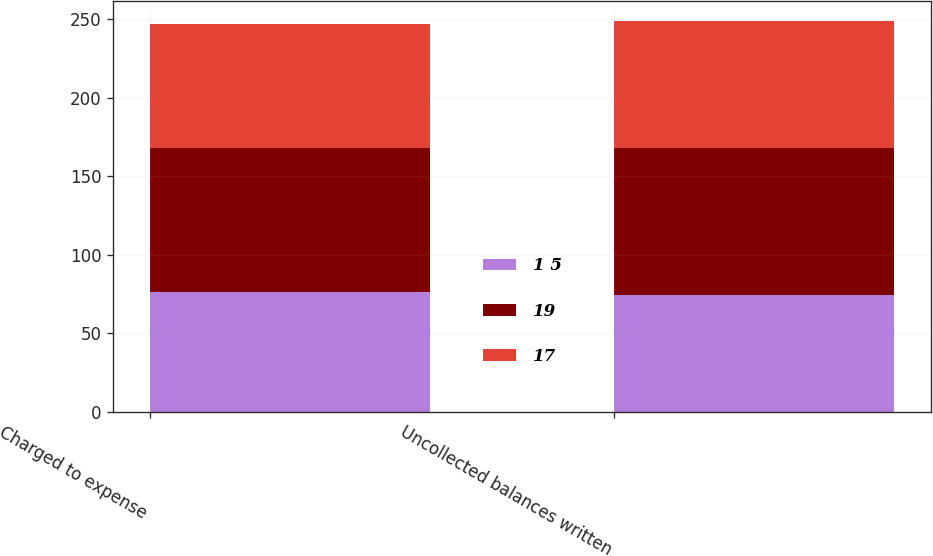Convert chart to OTSL. <chart><loc_0><loc_0><loc_500><loc_500><stacked_bar_chart><ecel><fcel>Charged to expense<fcel>Uncollected balances written<nl><fcel>1 5<fcel>76<fcel>74<nl><fcel>19<fcel>92<fcel>94<nl><fcel>17<fcel>79<fcel>81<nl></chart> 